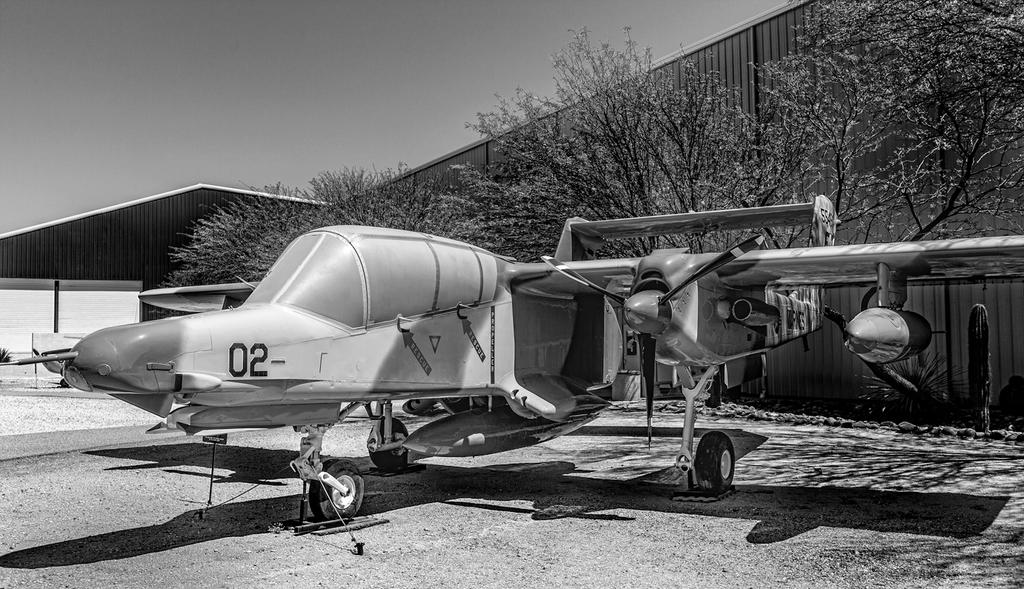What is the main subject of the image? The main subject of the image is a helicopter. What else can be seen in the image besides the helicopter? There are plants visible in the image. What is visible in the background of the image? In the background of the image, there are trees, buildings, and the sky. What type of pollution can be seen coming from the helicopter in the image? There is no pollution visible coming from the helicopter in the image. 